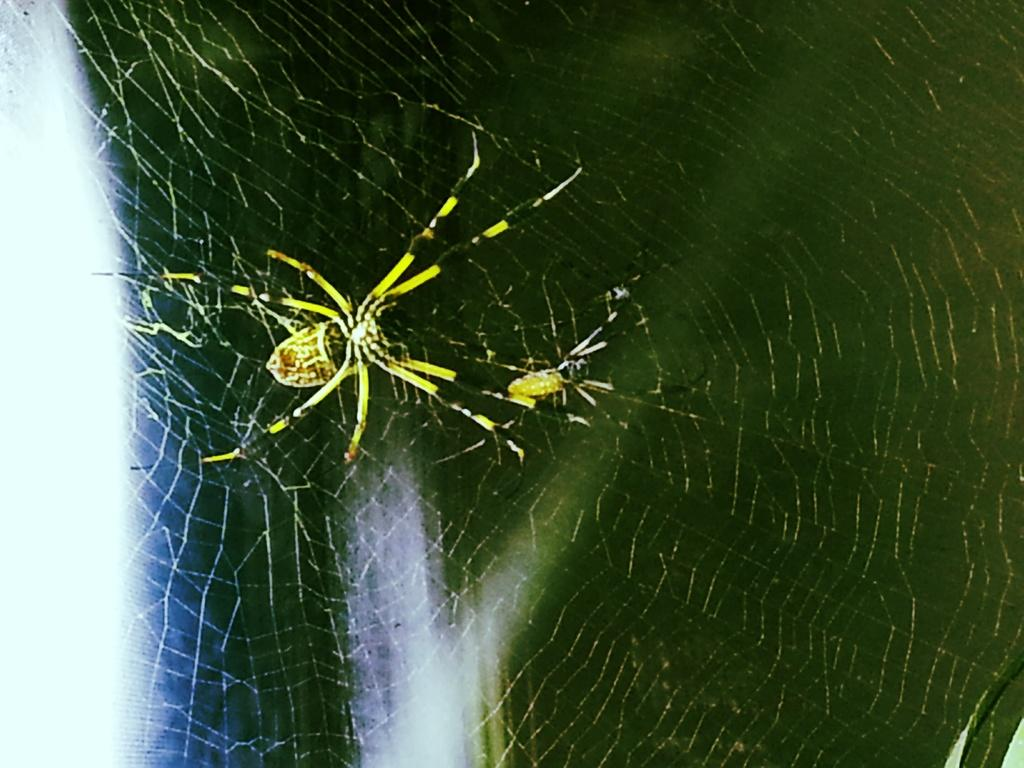What is the main subject of the image? There is a spider in the image. Where is the spider located? The spider is on a spider web. Can you describe the background of the image? The background of the image is blurry. How many spots can be seen on the spider in the image? There are no spots visible on the spider in the image. What type of pizzas are being served in the image? There are no pizzas present in the image. 